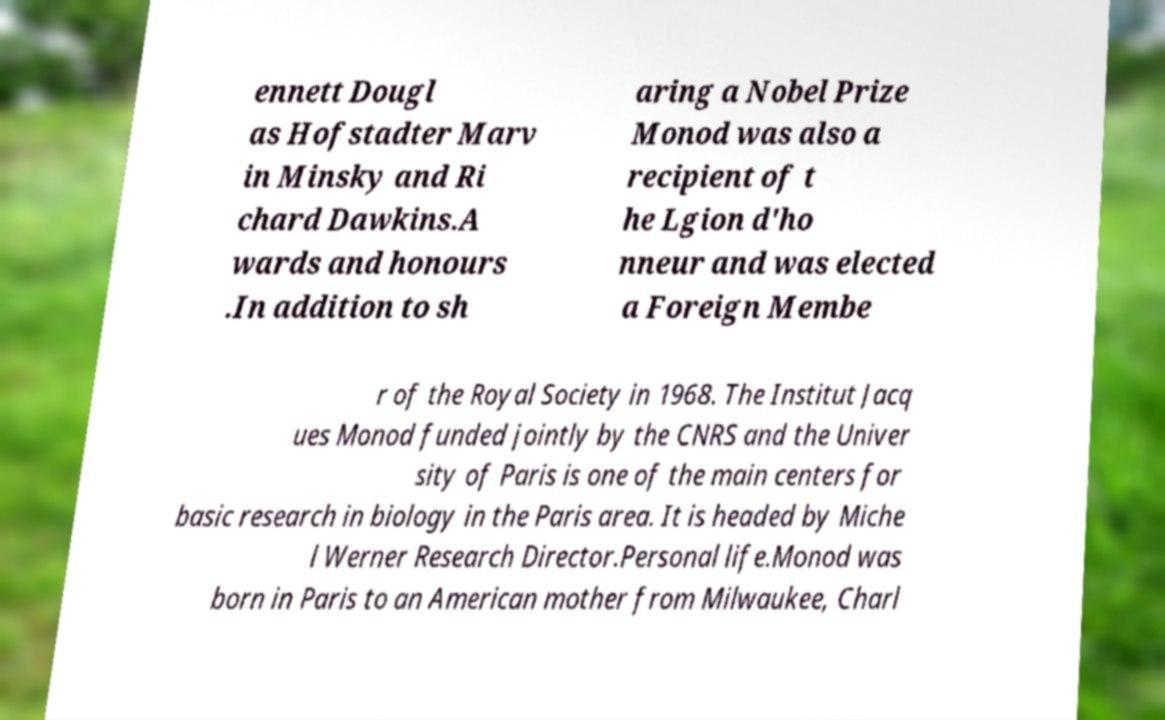There's text embedded in this image that I need extracted. Can you transcribe it verbatim? ennett Dougl as Hofstadter Marv in Minsky and Ri chard Dawkins.A wards and honours .In addition to sh aring a Nobel Prize Monod was also a recipient of t he Lgion d'ho nneur and was elected a Foreign Membe r of the Royal Society in 1968. The Institut Jacq ues Monod funded jointly by the CNRS and the Univer sity of Paris is one of the main centers for basic research in biology in the Paris area. It is headed by Miche l Werner Research Director.Personal life.Monod was born in Paris to an American mother from Milwaukee, Charl 